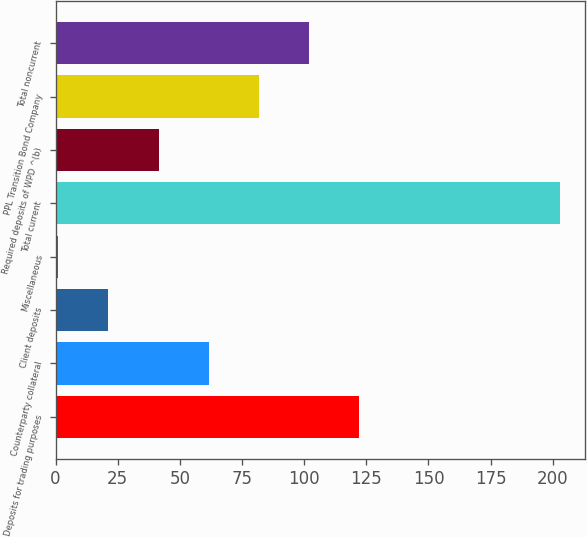Convert chart to OTSL. <chart><loc_0><loc_0><loc_500><loc_500><bar_chart><fcel>Deposits for trading purposes<fcel>Counterparty collateral<fcel>Client deposits<fcel>Miscellaneous<fcel>Total current<fcel>Required deposits of WPD ^(b)<fcel>PPL Transition Bond Company<fcel>Total noncurrent<nl><fcel>122.2<fcel>61.6<fcel>21.2<fcel>1<fcel>203<fcel>41.4<fcel>81.8<fcel>102<nl></chart> 